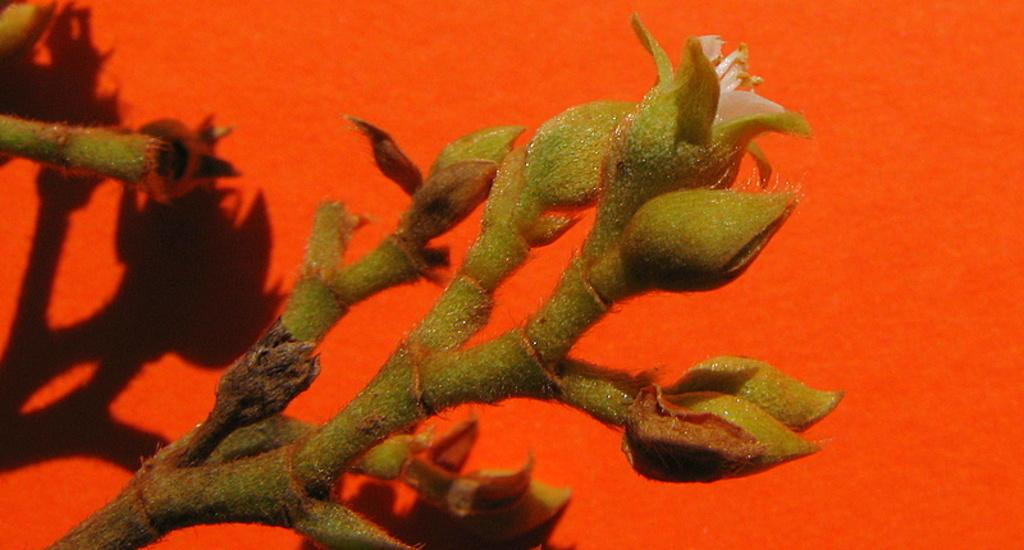What is the color of the background in the image? The background of the image is red in color. What can be seen on the red surface? There is a shadow visible on the red surface. What type of plant elements are present in the image? The image contains stems and buds. What type of education is being provided in the image? There is no indication of education in the image; it contains a red background, a shadow, stems, and buds. Can you see a plane flying in the image? There is no plane visible in the image. 